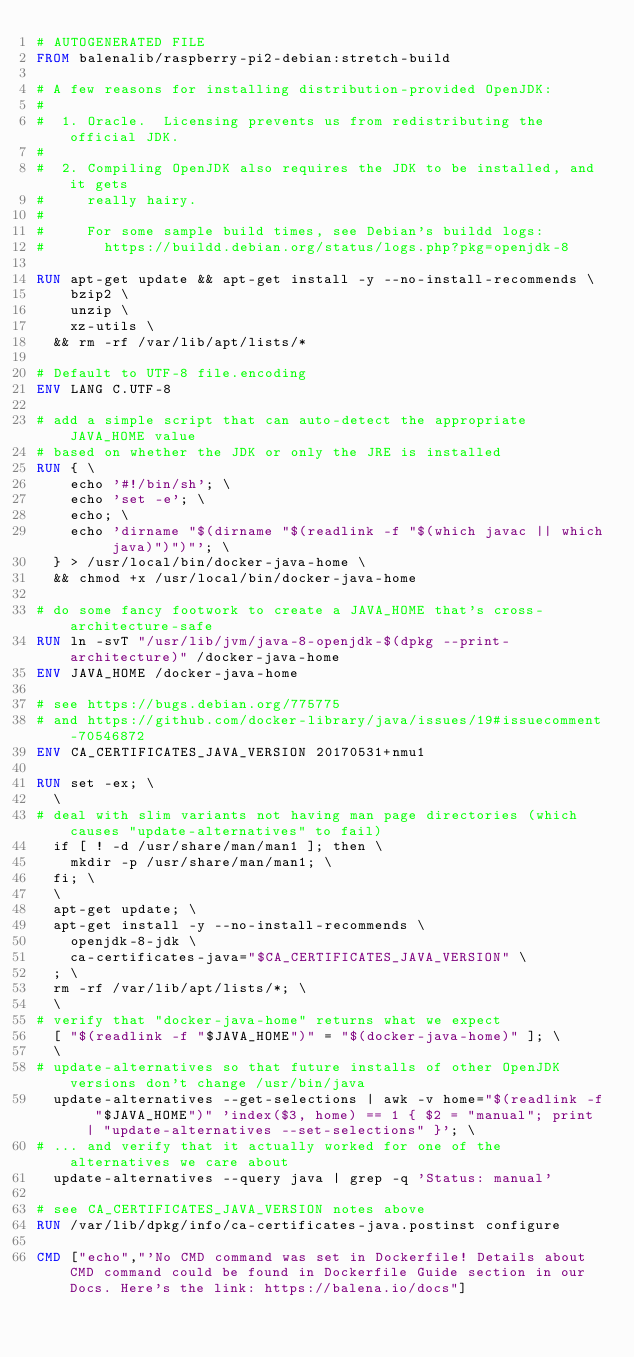<code> <loc_0><loc_0><loc_500><loc_500><_Dockerfile_># AUTOGENERATED FILE
FROM balenalib/raspberry-pi2-debian:stretch-build

# A few reasons for installing distribution-provided OpenJDK:
#
#  1. Oracle.  Licensing prevents us from redistributing the official JDK.
#
#  2. Compiling OpenJDK also requires the JDK to be installed, and it gets
#     really hairy.
#
#     For some sample build times, see Debian's buildd logs:
#       https://buildd.debian.org/status/logs.php?pkg=openjdk-8

RUN apt-get update && apt-get install -y --no-install-recommends \
		bzip2 \
		unzip \
		xz-utils \
	&& rm -rf /var/lib/apt/lists/*

# Default to UTF-8 file.encoding
ENV LANG C.UTF-8

# add a simple script that can auto-detect the appropriate JAVA_HOME value
# based on whether the JDK or only the JRE is installed
RUN { \
		echo '#!/bin/sh'; \
		echo 'set -e'; \
		echo; \
		echo 'dirname "$(dirname "$(readlink -f "$(which javac || which java)")")"'; \
	} > /usr/local/bin/docker-java-home \
	&& chmod +x /usr/local/bin/docker-java-home

# do some fancy footwork to create a JAVA_HOME that's cross-architecture-safe
RUN ln -svT "/usr/lib/jvm/java-8-openjdk-$(dpkg --print-architecture)" /docker-java-home
ENV JAVA_HOME /docker-java-home

# see https://bugs.debian.org/775775
# and https://github.com/docker-library/java/issues/19#issuecomment-70546872
ENV CA_CERTIFICATES_JAVA_VERSION 20170531+nmu1

RUN set -ex; \
	\
# deal with slim variants not having man page directories (which causes "update-alternatives" to fail)
	if [ ! -d /usr/share/man/man1 ]; then \
		mkdir -p /usr/share/man/man1; \
	fi; \
	\
	apt-get update; \
	apt-get install -y --no-install-recommends \
		openjdk-8-jdk \
		ca-certificates-java="$CA_CERTIFICATES_JAVA_VERSION" \
	; \
	rm -rf /var/lib/apt/lists/*; \
	\
# verify that "docker-java-home" returns what we expect
	[ "$(readlink -f "$JAVA_HOME")" = "$(docker-java-home)" ]; \
	\
# update-alternatives so that future installs of other OpenJDK versions don't change /usr/bin/java
	update-alternatives --get-selections | awk -v home="$(readlink -f "$JAVA_HOME")" 'index($3, home) == 1 { $2 = "manual"; print | "update-alternatives --set-selections" }'; \
# ... and verify that it actually worked for one of the alternatives we care about
	update-alternatives --query java | grep -q 'Status: manual'

# see CA_CERTIFICATES_JAVA_VERSION notes above
RUN /var/lib/dpkg/info/ca-certificates-java.postinst configure

CMD ["echo","'No CMD command was set in Dockerfile! Details about CMD command could be found in Dockerfile Guide section in our Docs. Here's the link: https://balena.io/docs"]</code> 